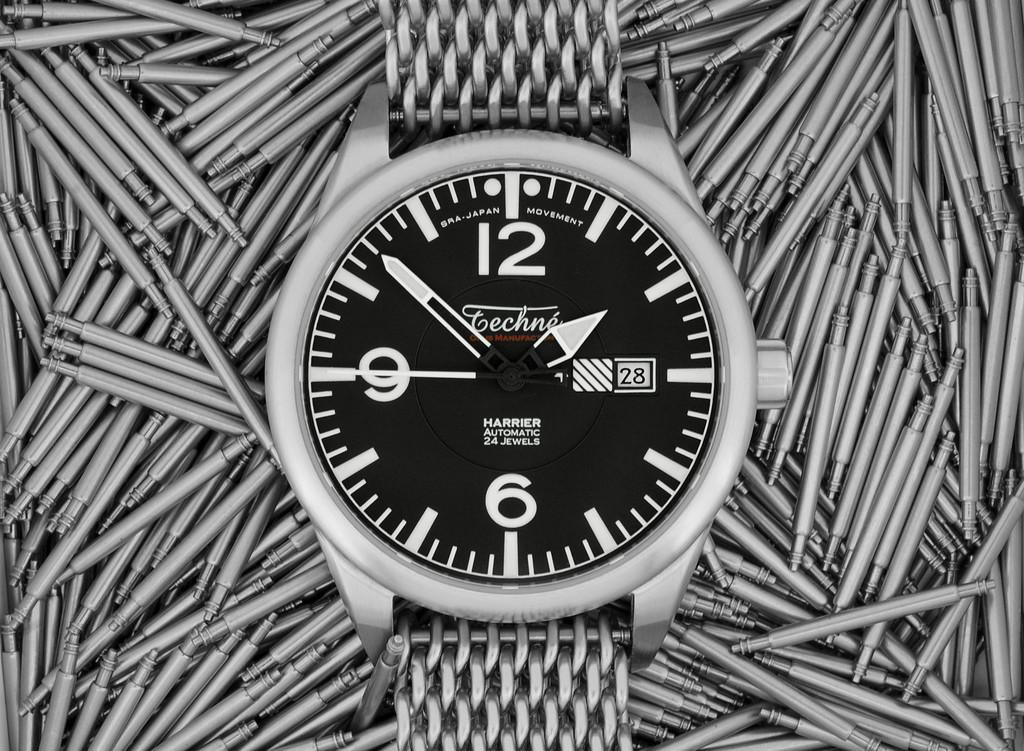<image>
Offer a succinct explanation of the picture presented. A Harrier Automatic 24 Jewels watch has a silver wristband. 